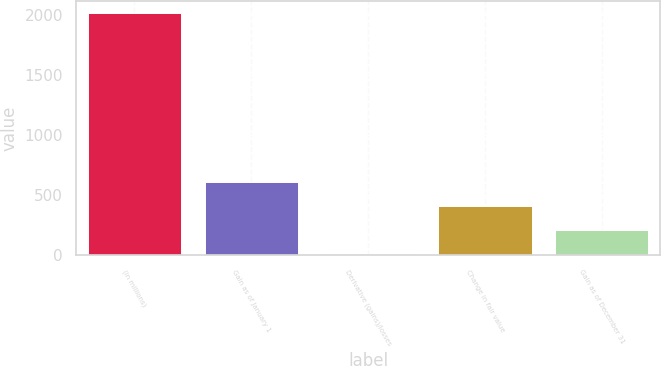Convert chart to OTSL. <chart><loc_0><loc_0><loc_500><loc_500><bar_chart><fcel>(in millions)<fcel>Gain as of January 1<fcel>Derivative (gains)/losses<fcel>Change in fair value<fcel>Gain as of December 31<nl><fcel>2017<fcel>612.8<fcel>11<fcel>412.2<fcel>211.6<nl></chart> 